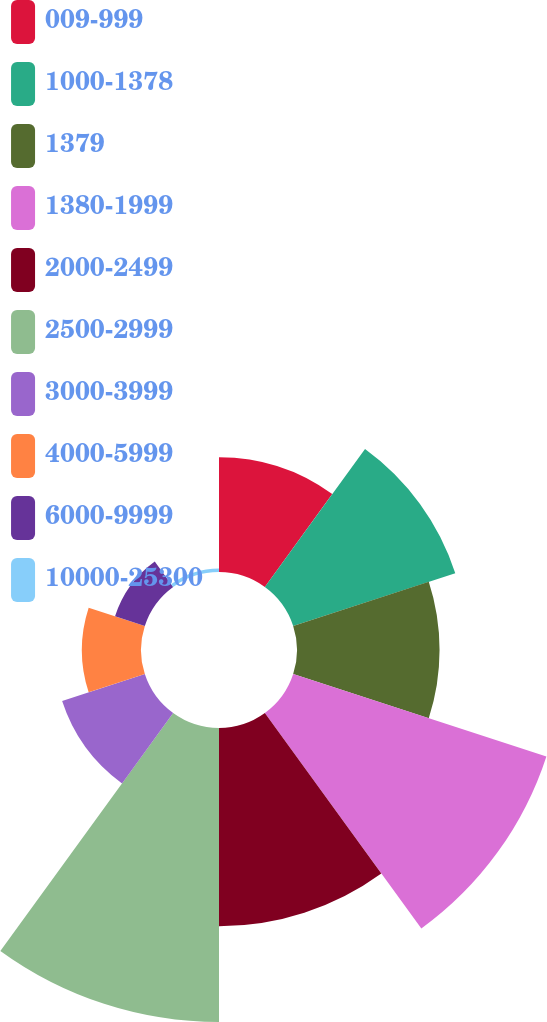<chart> <loc_0><loc_0><loc_500><loc_500><pie_chart><fcel>009-999<fcel>1000-1378<fcel>1379<fcel>1380-1999<fcel>2000-2499<fcel>2500-2999<fcel>3000-3999<fcel>4000-5999<fcel>6000-9999<fcel>10000-25300<nl><fcel>8.39%<fcel>12.47%<fcel>10.43%<fcel>19.48%<fcel>14.5%<fcel>21.51%<fcel>6.36%<fcel>4.32%<fcel>2.29%<fcel>0.25%<nl></chart> 